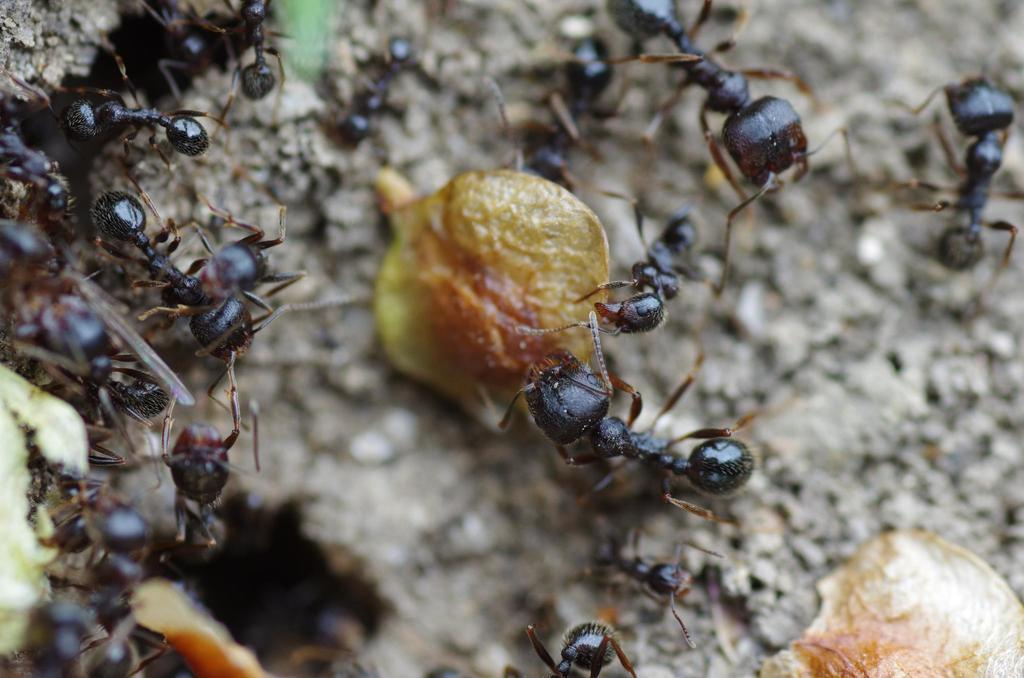What type of creatures can be seen in the image? There are ants in the image. What else is present on the surface in the image? There are objects on the surface in the image. What type of garden can be seen in the image? There is no garden present in the image; it only features ants and objects on a surface. What is the reaction of the ants to the objects in the image? The image does not show the ants' reactions to the objects, as it only depicts their presence on the surface. 